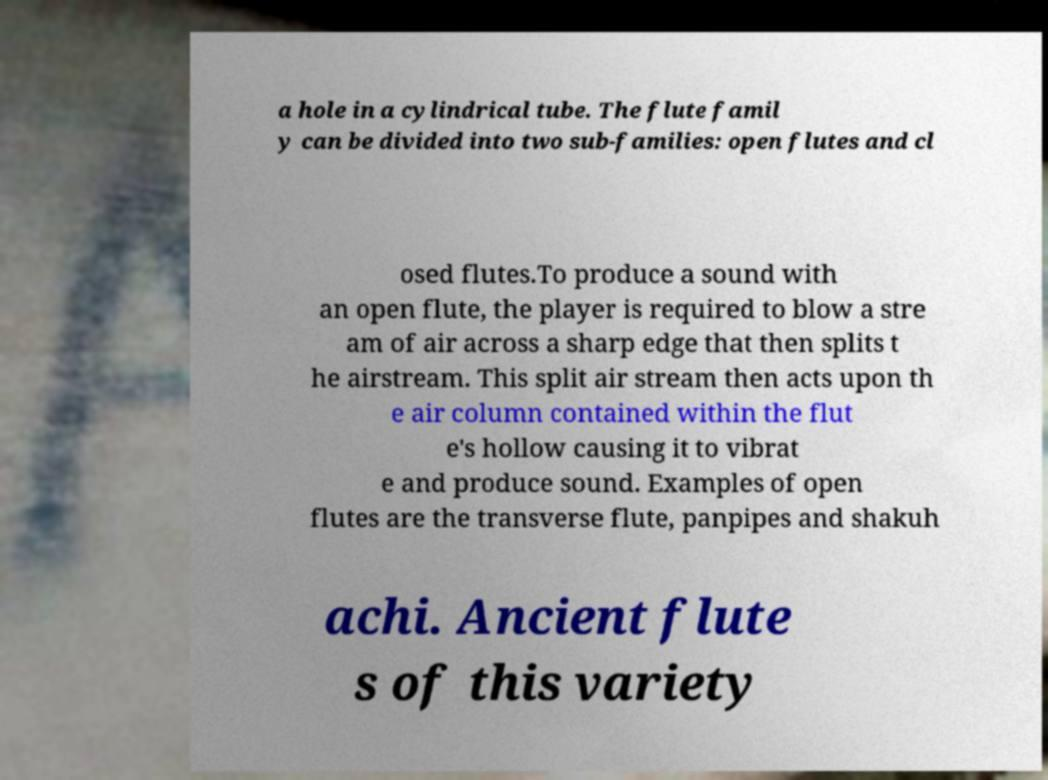I need the written content from this picture converted into text. Can you do that? a hole in a cylindrical tube. The flute famil y can be divided into two sub-families: open flutes and cl osed flutes.To produce a sound with an open flute, the player is required to blow a stre am of air across a sharp edge that then splits t he airstream. This split air stream then acts upon th e air column contained within the flut e's hollow causing it to vibrat e and produce sound. Examples of open flutes are the transverse flute, panpipes and shakuh achi. Ancient flute s of this variety 